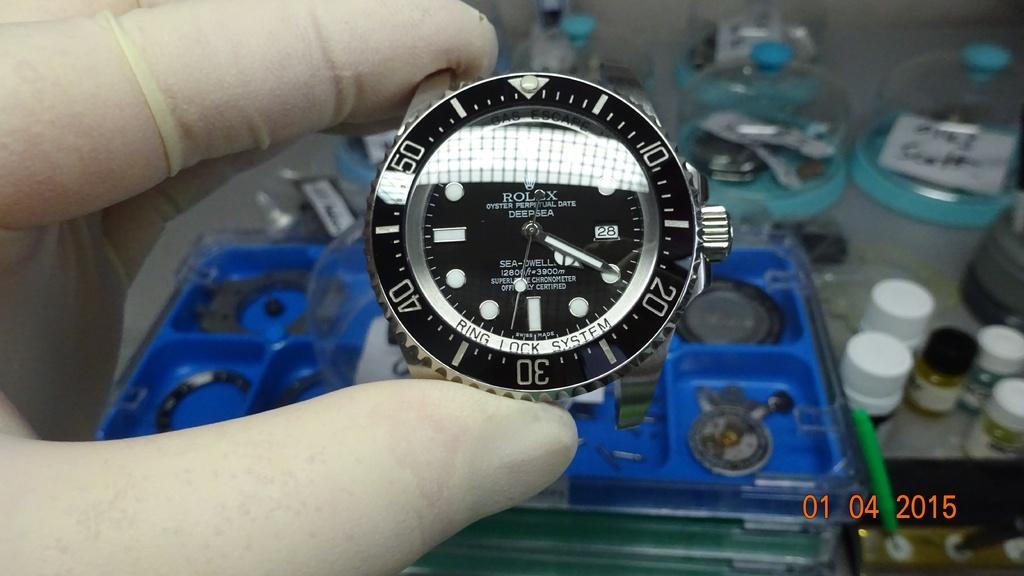<image>
Give a short and clear explanation of the subsequent image. Someone holds a Rolex watch face in their hand with gloves on. 